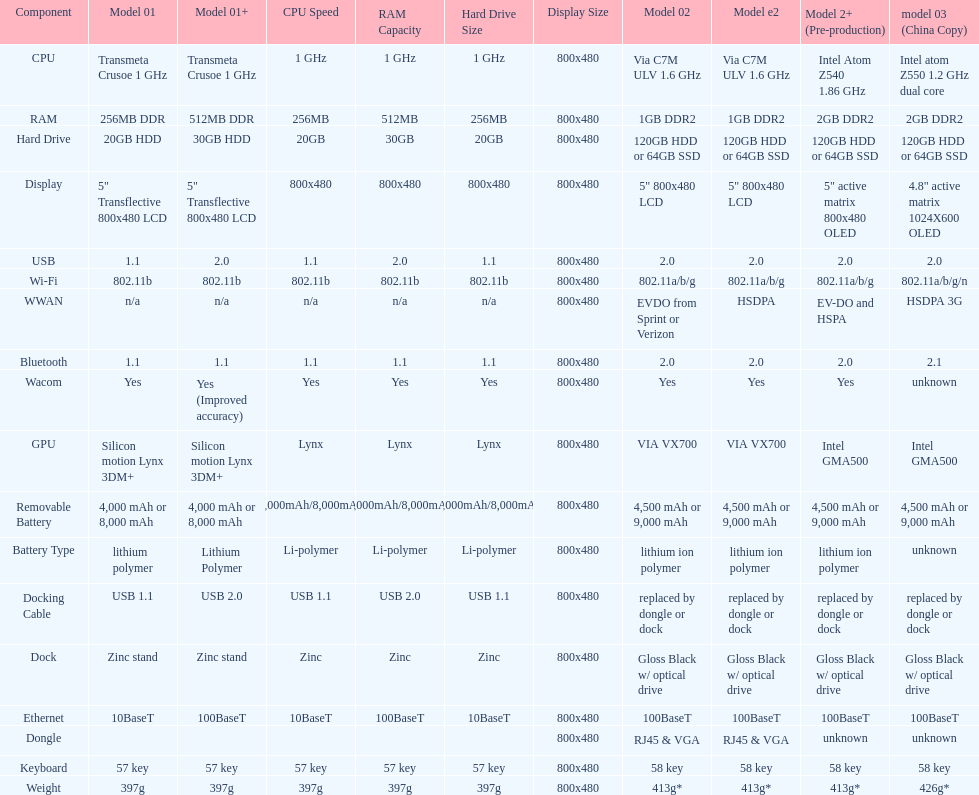What comes after the 30gb model in terms of higher capacity hard drives? 64GB SSD. 